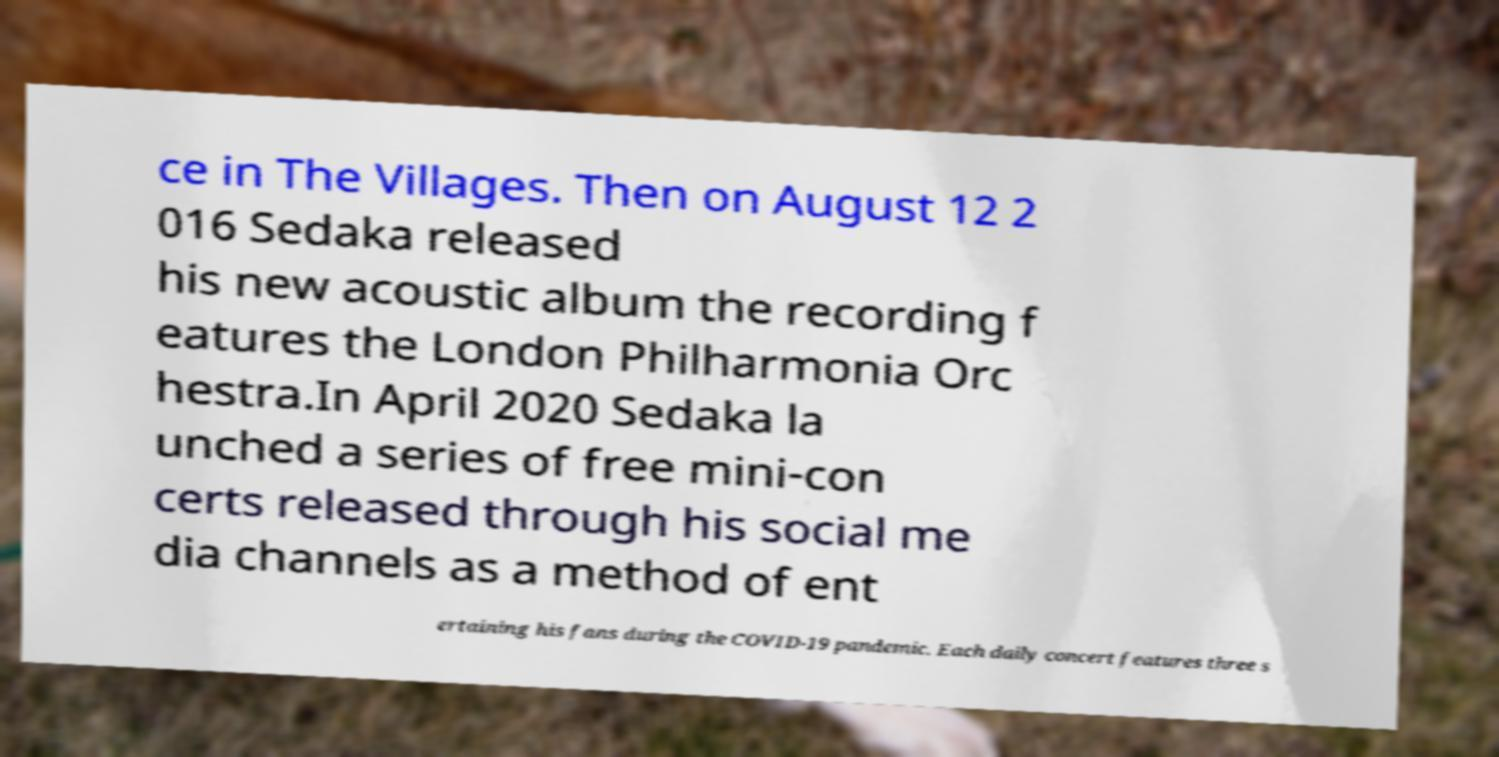Please read and relay the text visible in this image. What does it say? ce in The Villages. Then on August 12 2 016 Sedaka released his new acoustic album the recording f eatures the London Philharmonia Orc hestra.In April 2020 Sedaka la unched a series of free mini-con certs released through his social me dia channels as a method of ent ertaining his fans during the COVID-19 pandemic. Each daily concert features three s 